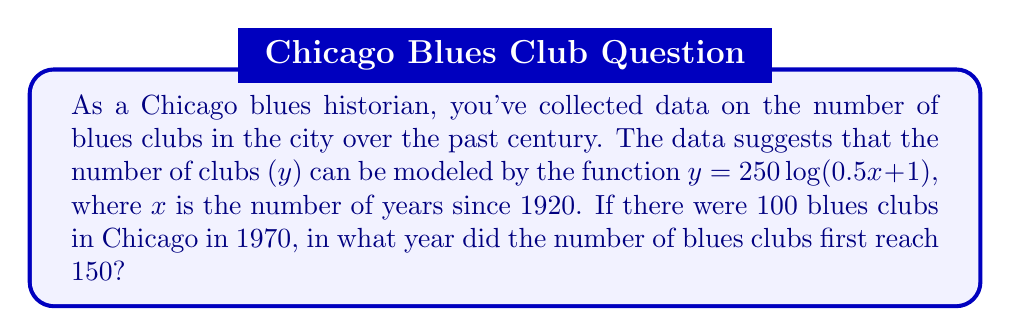Teach me how to tackle this problem. Let's approach this step-by-step:

1) We're given the function $y = 250 \log(0.5x + 1)$, where y is the number of clubs and x is years since 1920.

2) We need to find when y = 150. So, let's set up the equation:

   $150 = 250 \log(0.5x + 1)$

3) Divide both sides by 250:

   $\frac{150}{250} = \log(0.5x + 1)$
   $0.6 = \log(0.5x + 1)$

4) Now, we need to solve for x. Let's apply the exponential function to both sides:

   $e^{0.6} = 0.5x + 1$

5) Subtract 1 from both sides:

   $e^{0.6} - 1 = 0.5x$

6) Multiply both sides by 2:

   $2(e^{0.6} - 1) = x$

7) Calculate this value:

   $x \approx 1.64396$

8) Remember, x is years since 1920. So, we need to add 1920 to get the actual year:

   $1920 + 1.64396 \approx 1921.64$

9) Since we're dealing with years, we round up to the nearest whole year: 1922.

10) To verify, we can check if there were indeed 100 clubs in 1970:
    For 1970, x = 1970 - 1920 = 50
    $y = 250 \log(0.5(50) + 1) \approx 100.27$

    This confirms our calculation is correct.
Answer: The number of blues clubs in Chicago first reached 150 in 1922. 